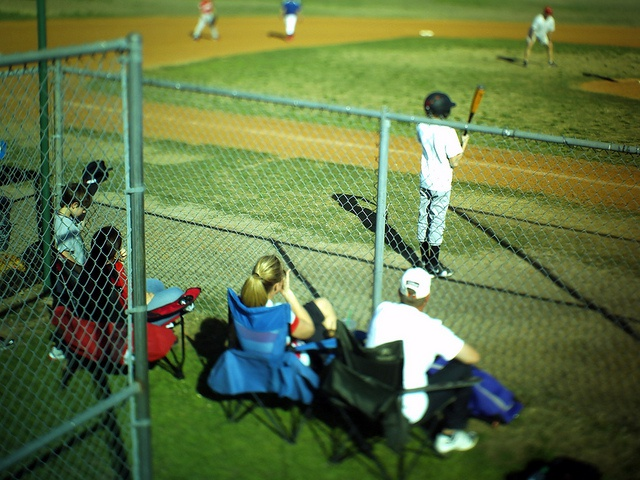Describe the objects in this image and their specific colors. I can see chair in darkgreen, black, and white tones, chair in darkgreen, teal, black, gray, and blue tones, chair in darkgreen, black, maroon, brown, and gray tones, people in darkgreen, white, olive, and lightblue tones, and people in darkgreen, white, black, lightblue, and teal tones in this image. 